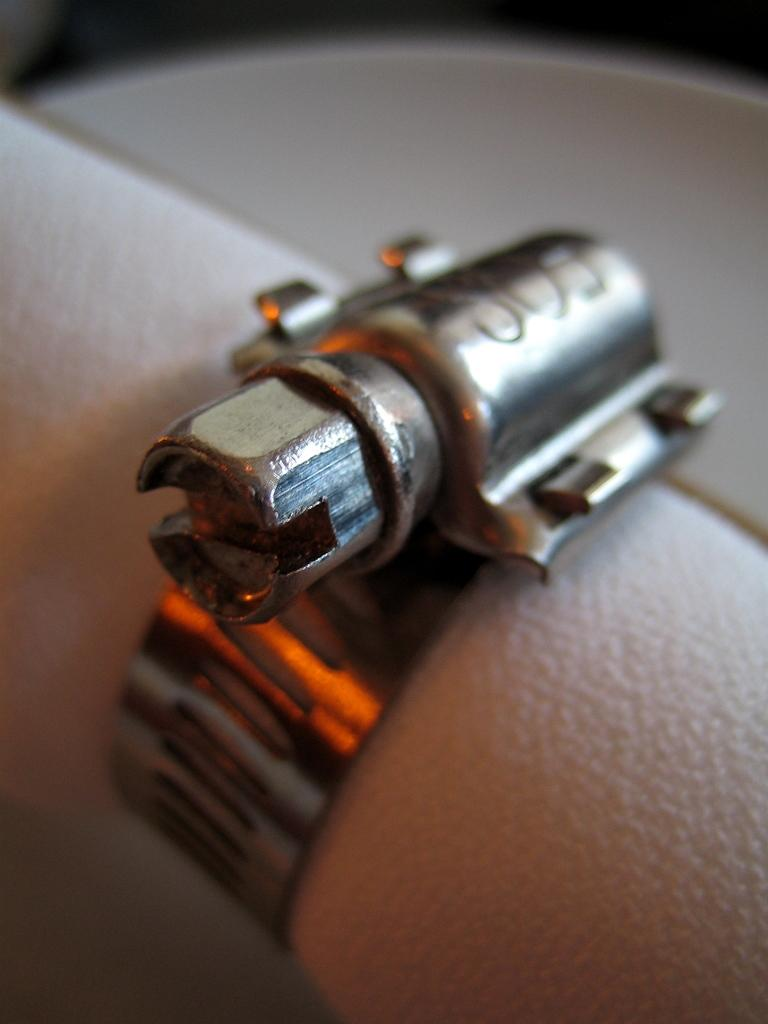What is the main subject of the image? The main subject of the image appears to be a metal joint. Can you describe the connection of the metal joint in the image? The metal joint is connected to a hand. How many friends are present in the image? There is no indication of friends in the image; it depicts a metal joint connected to a hand. What type of secretary is shown working in the image? There is no secretary present in the image; it depicts a metal joint connected to a hand. 